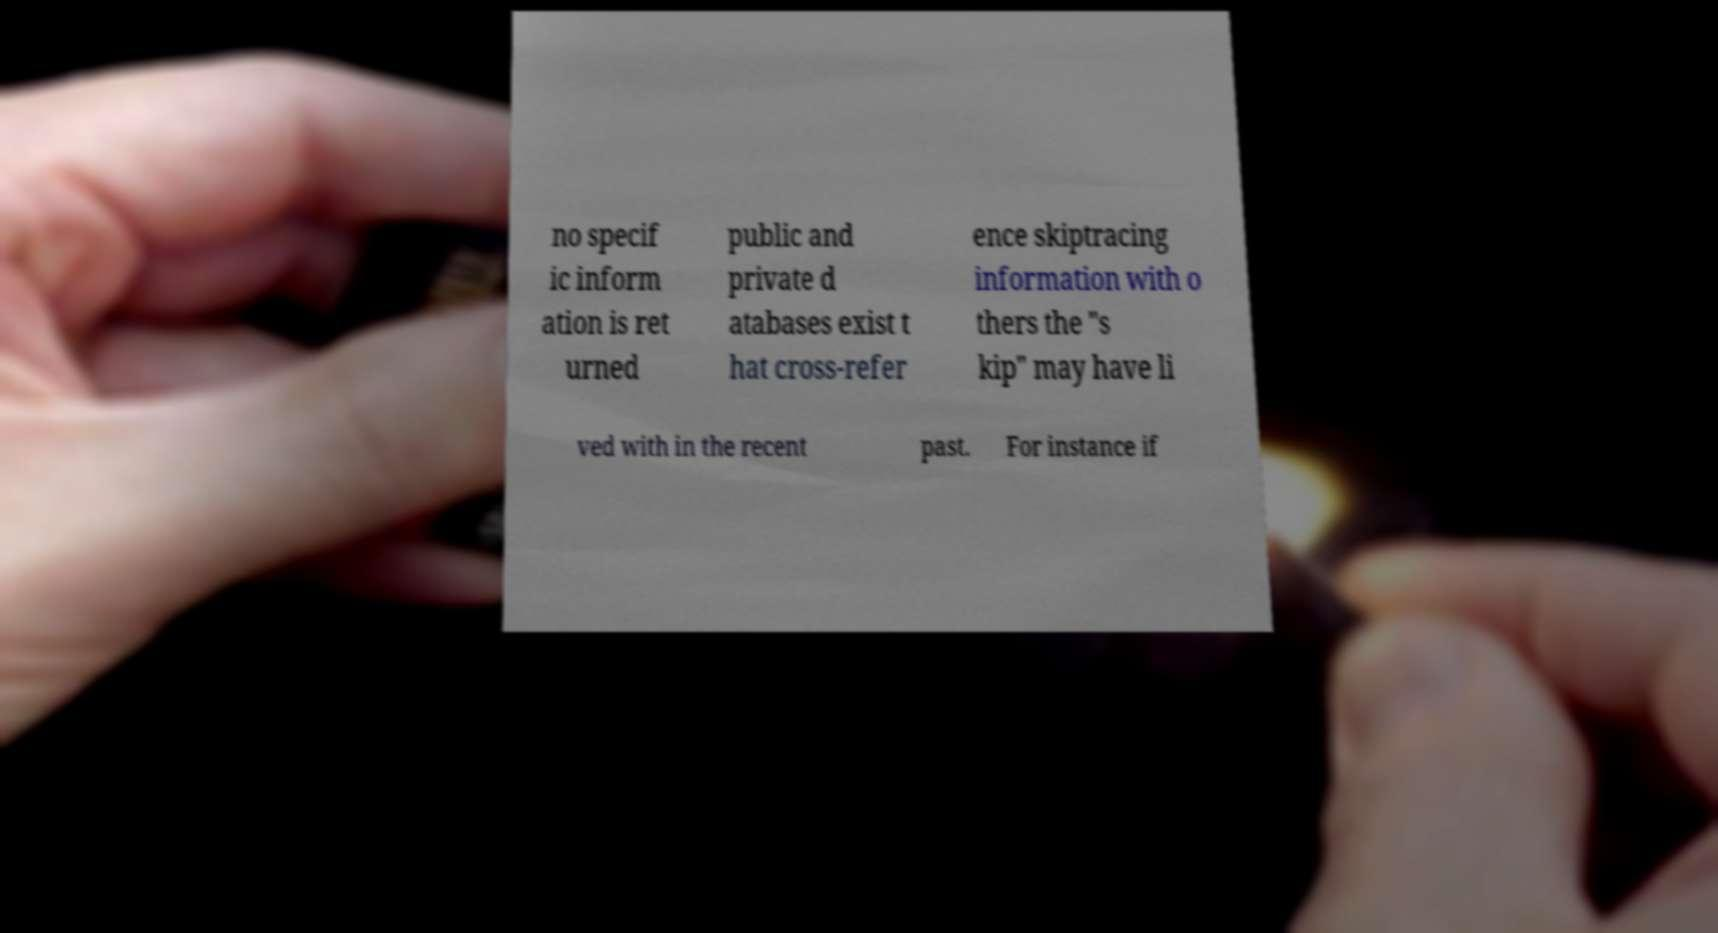Please read and relay the text visible in this image. What does it say? no specif ic inform ation is ret urned public and private d atabases exist t hat cross-refer ence skiptracing information with o thers the "s kip" may have li ved with in the recent past. For instance if 